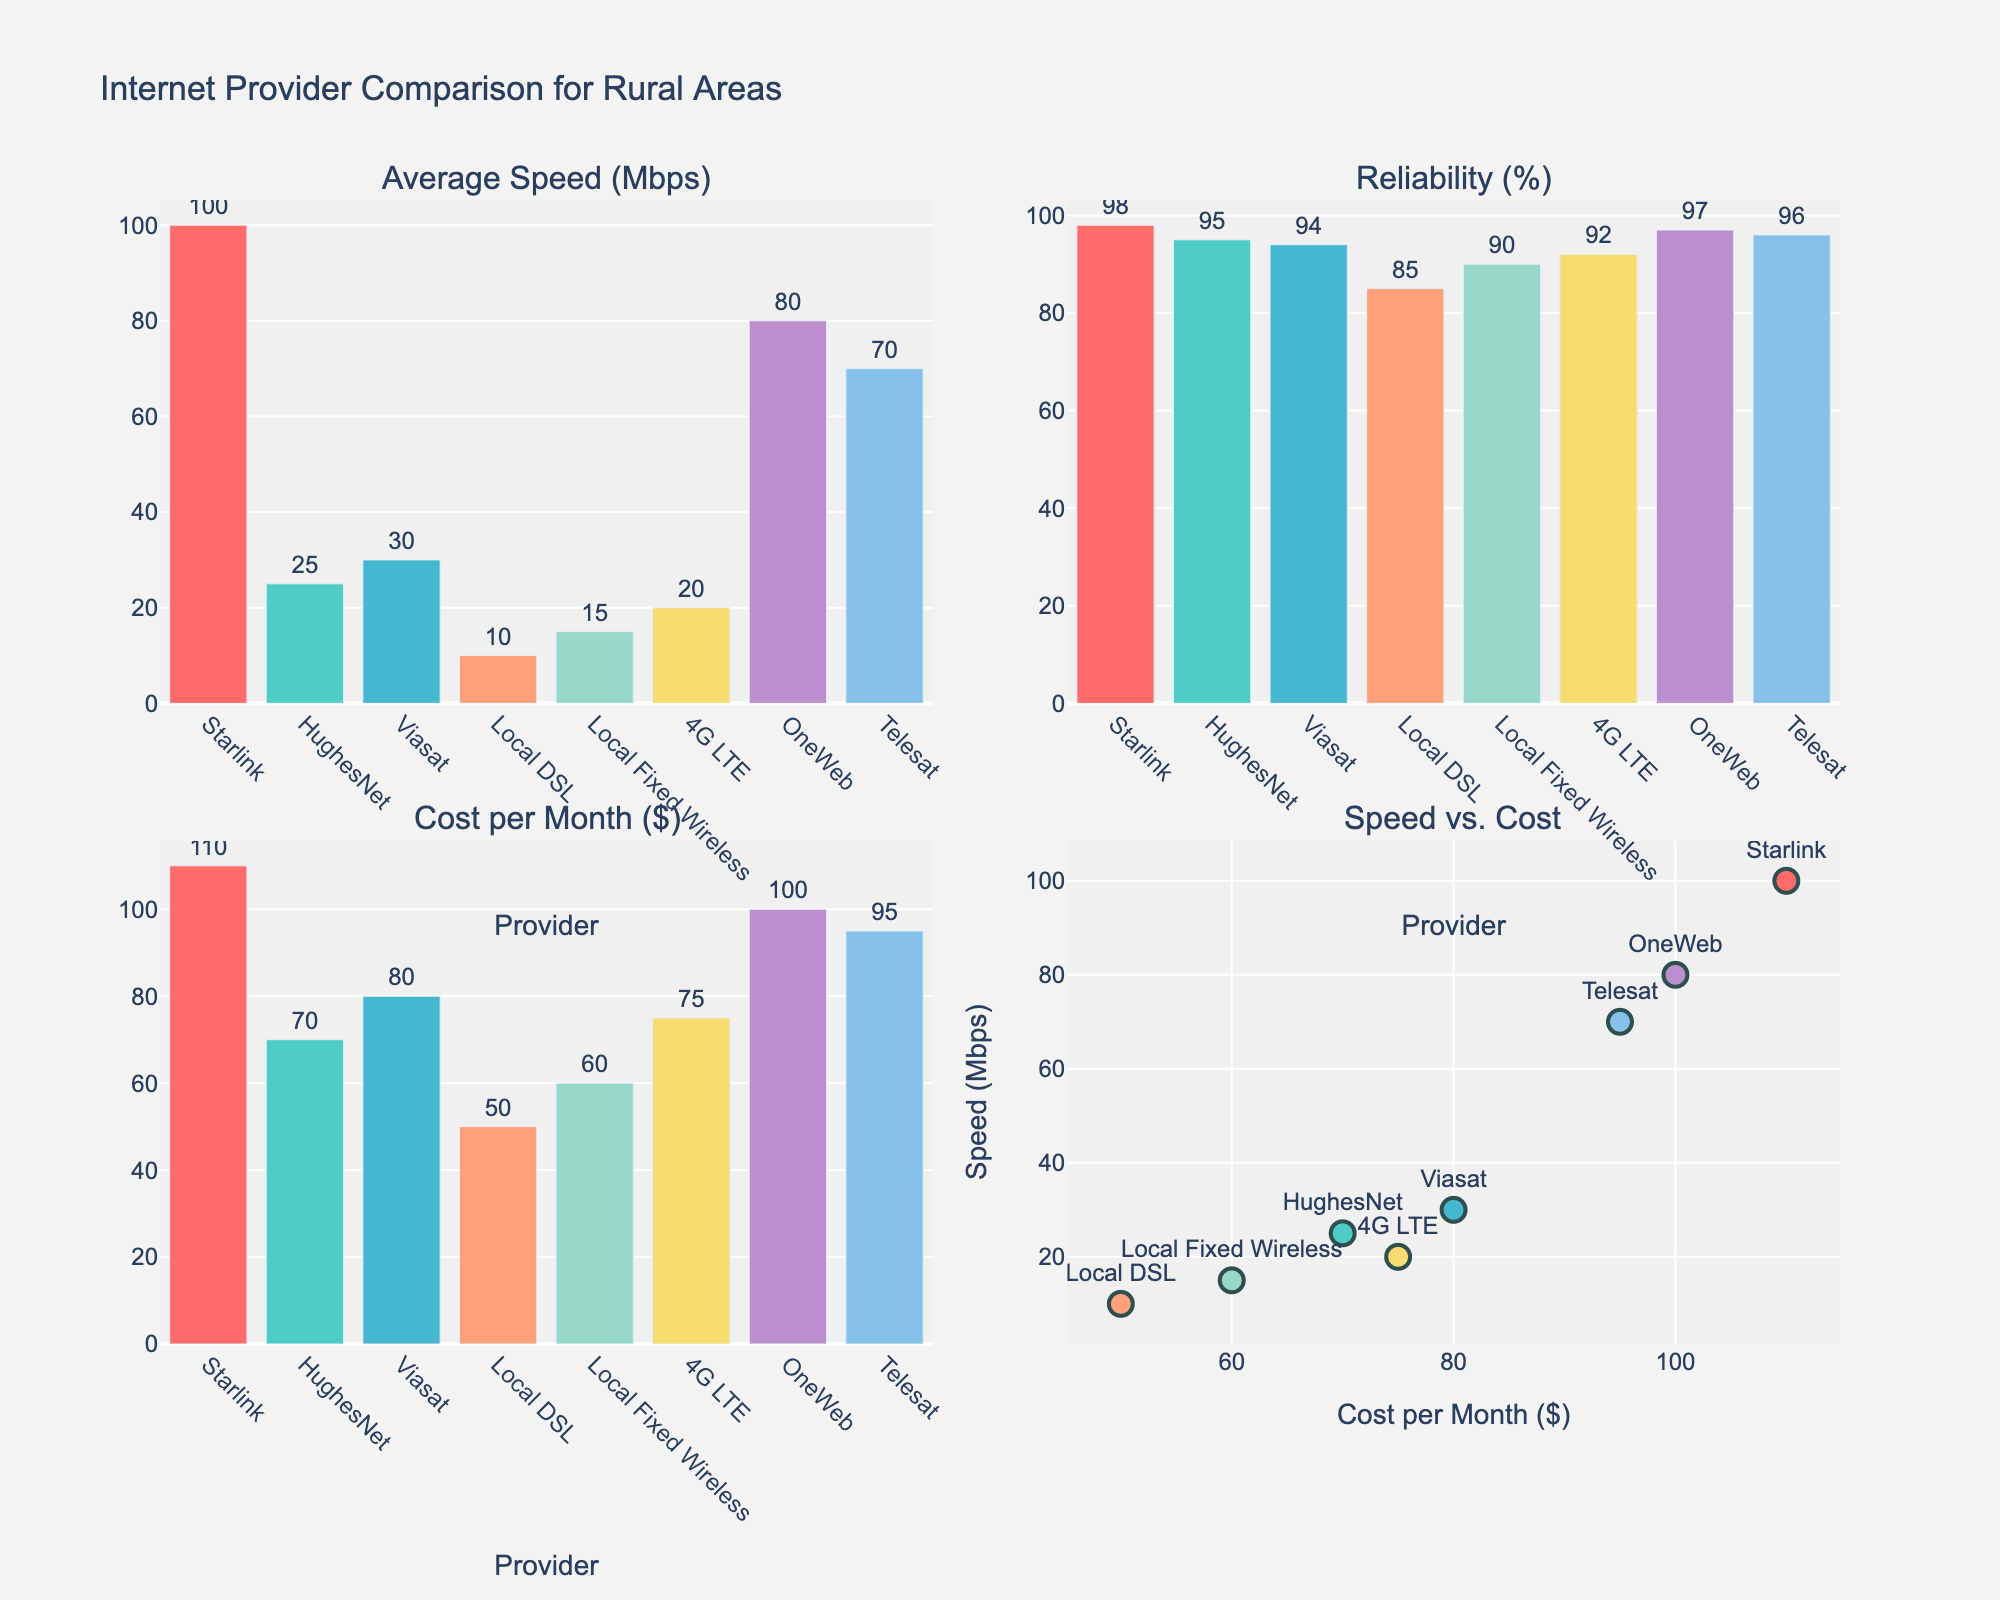What is the main title of the figure? The main title is located at the top center of the figure and clearly states the subject of the plot.
Answer: Distribution of Radio Content Genres on ABC Radio Stations Which genre appears with the highest percentage for ABC Classic at midnight (0:00)? Look at the subplot for ABC Classic and identify the data point closest to '0:00', then find the highest percentage value among the genres at that time.
Answer: Music How does the percentage of News content on ABC Radio National change from 6:00 to 12:00? Locate the subplot for ABC Radio National and observe the percentage values for News at 6:00 and 12:00. Subtract the percentage at 12:00 from the percentage at 6:00.
Answer: Decreases by 10% Which station has the highest percentage of Comedy content at 6:00? Compare the Comedy content percentages at 6:00 across all four subplots to identify which station has the highest value.
Answer: ABC Radio National What is the average percentage of Music content on Triple J throughout the day? Sum the Music percentages for Triple J at all four times (6:00, 12:00, 18:00, 0:00) and divide by 4.
Answer: 68.75% During which time period does ABC Local Radio have the highest percentage of Talk content? Look at the ABC Local Radio subplot and identify which time (6:00, 12:00, 18:00, 0:00) has the highest percentage value for Talk content.
Answer: 12:00 Compare the Drama content percentages between ABC Classic and Triple J at 18:00. Which station has a higher percentage and by how much? Find the Drama content values at 18:00 in both ABC Classic and Triple J subplots, then subtract the lower percentage from the higher one and specify which station has more.
Answer: ABC Classic by 5% How does the distribution of content genres differ between ABC Classic and ABC Radio National at 18:00? Compare the percentage values of all genres at 18:00 for both ABC Classic and ABC Radio National and describe the key differences.
Answer: ABC Classic has more Music, less News and Talk, and similar Comedy and Drama percentages Which genre is consistently low across all stations and times? Examine all subplots and identify the genre with consistently low values across all times and stations.
Answer: Drama How many genres are displayed in each subplot? Count the number of distinct lines representing different genres in each subplot.
Answer: 5 